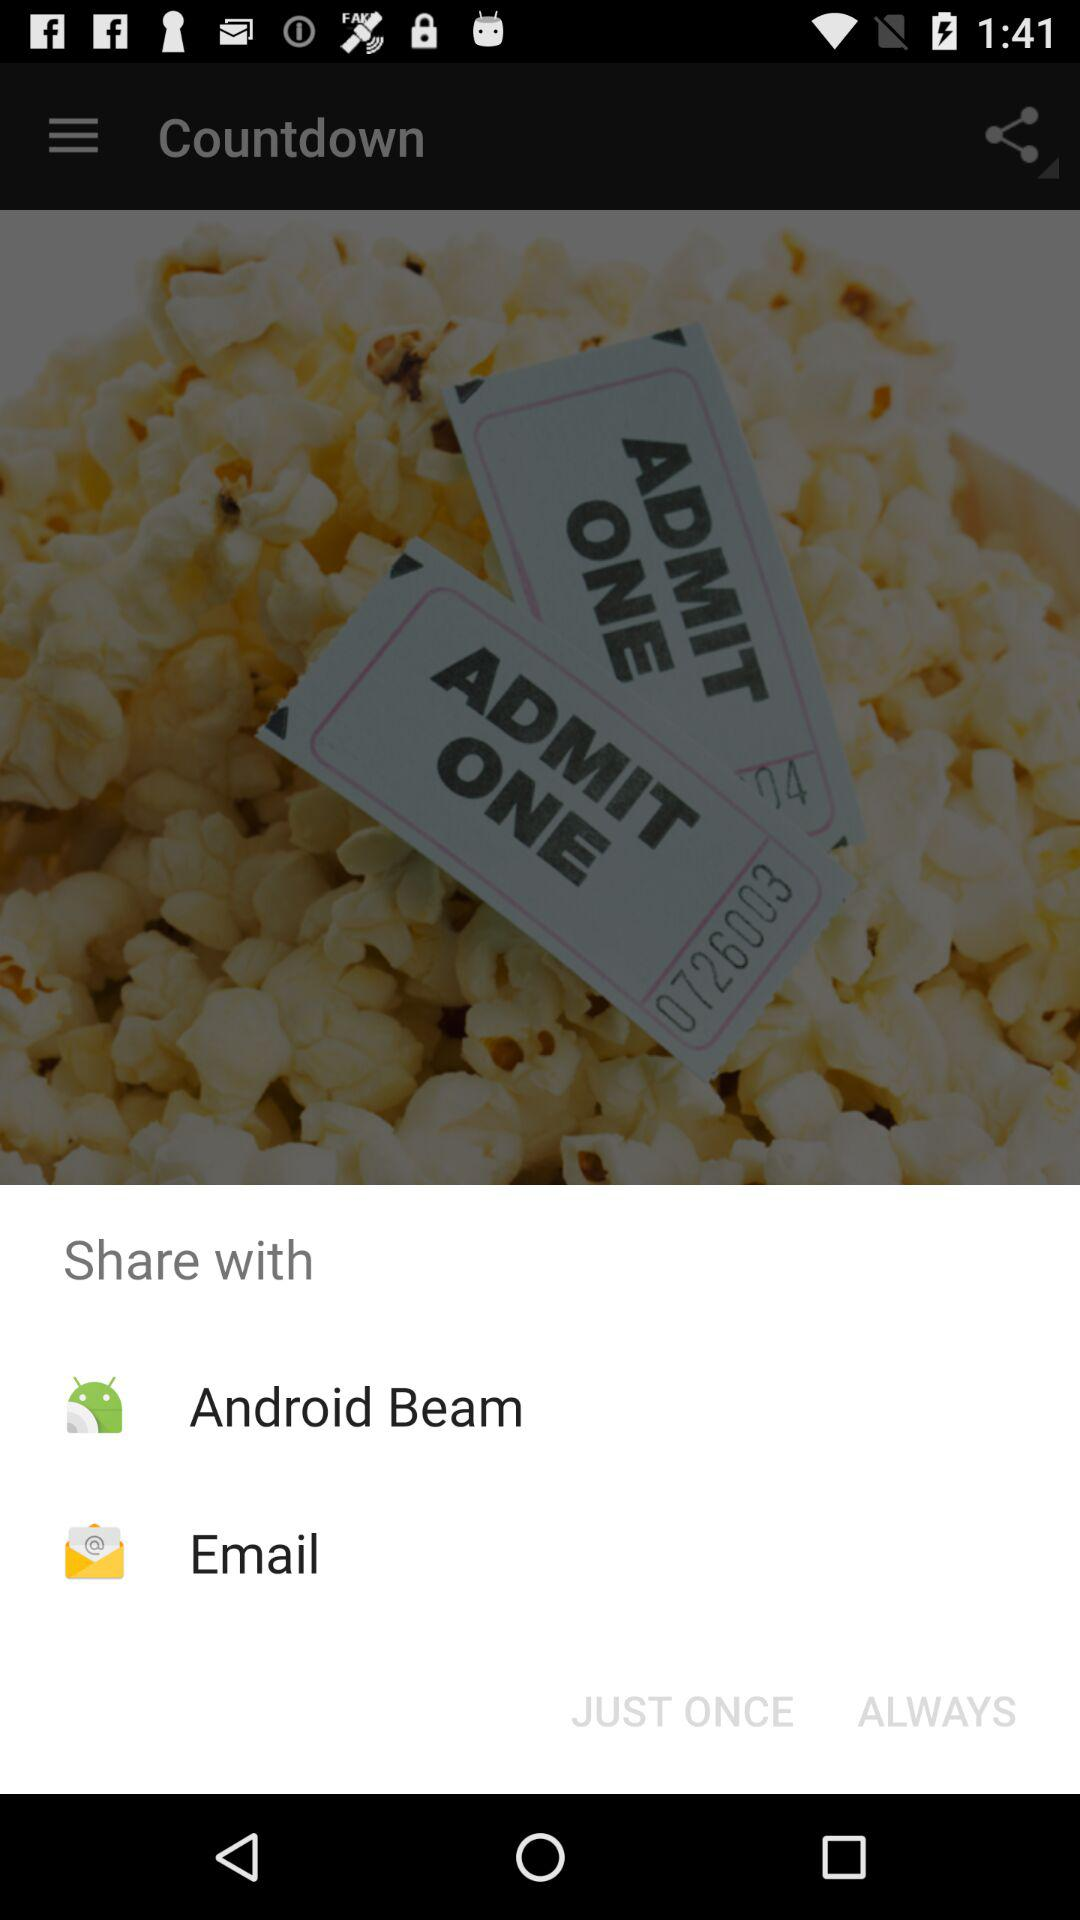Through which application can we share the image? You can share the image through "Android Beam". 